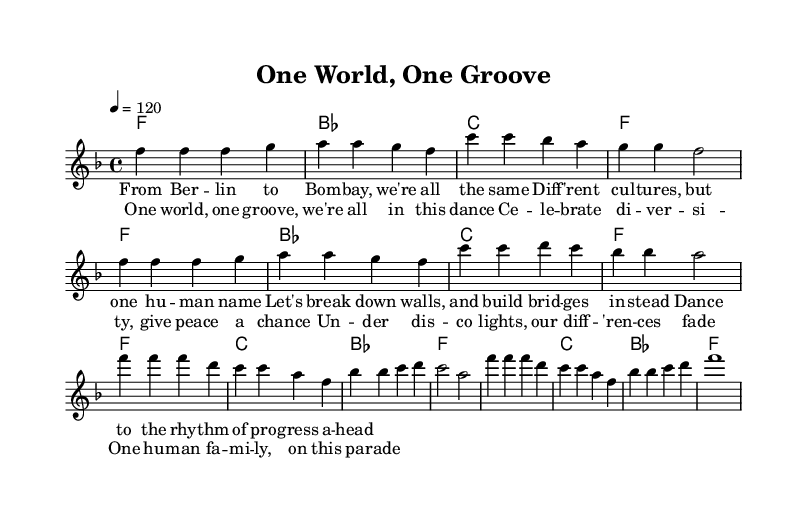What is the key signature of this music? The key signature is F major, which includes one flat (B flat). This is determined by examining the key signature section at the beginning of the sheet music.
Answer: F major What is the time signature of this piece? The time signature is 4/4, meaning there are four beats in each measure and the quarter note gets one beat. This can be seen directly in the time signature notation located at the start of the staff.
Answer: 4/4 What is the tempo marking for this piece? The tempo marking is 120 beats per minute, indicated by the notation "4 = 120" at the beginning of the global setup, which specifies the speed of the music.
Answer: 120 How many measures are in the chorus section? The chorus section consists of four measures. This can be counted by looking at the visual breakdown of the music, where the melody and lyrics align with four distinct measures during the chorus.
Answer: 4 What do the lyrics in the first verse emphasize about cultural diversity? The lyrics emphasize unity among different cultures by stating "Diff'rent cultures, but one human name," which reflects the theme of global unity in diversity within the context of the verse.
Answer: Unity in diversity What element of the song structure makes it a Disco anthem? One key element is the repetitive nature of the chorus combined with uplifting lyrics and a strong rhythmic foundation, which is characteristic of Disco music, inviting listeners to dance and engage.
Answer: Repetitive chorus How does this piece promote global unity? The lyrics and music collectively promote global unity by highlighting shared human experiences and celebrating diversity, particularly in the line "One world, one groove." This creates an inclusive message that resonates within the Disco genre.
Answer: Celebrating diversity 